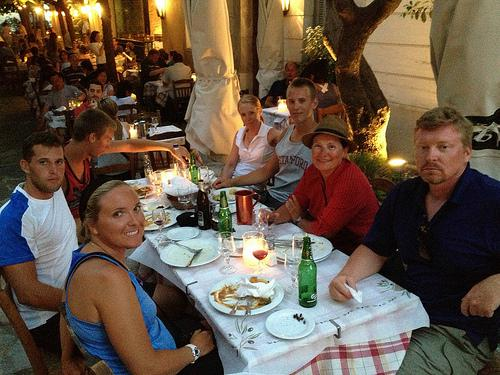Question: why did the family gather?
Choices:
A. Birthday party.
B. Dinner.
C. Thanksgiving.
D. Christmas.
Answer with the letter. Answer: B Question: how was the food delivered?
Choices:
A. Delivery driver.
B. Waiter.
C. On foot.
D. Mail.
Answer with the letter. Answer: B Question: where are the drinks setting?
Choices:
A. On the counter.
B. Table center.
C. On the floor.
D. At the bar.
Answer with the letter. Answer: B 